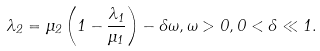Convert formula to latex. <formula><loc_0><loc_0><loc_500><loc_500>\lambda _ { 2 } = \mu _ { 2 } \left ( 1 - \frac { \lambda _ { 1 } } { \mu _ { 1 } } \right ) - \delta \omega , \omega > 0 , 0 < \delta \ll 1 .</formula> 